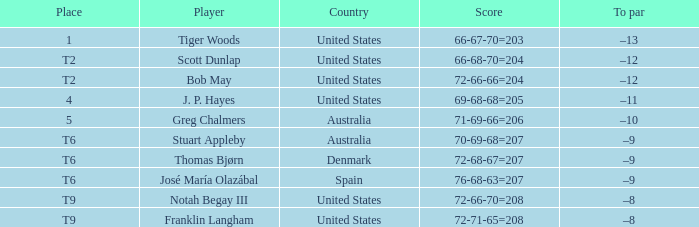Give me the full table as a dictionary. {'header': ['Place', 'Player', 'Country', 'Score', 'To par'], 'rows': [['1', 'Tiger Woods', 'United States', '66-67-70=203', '–13'], ['T2', 'Scott Dunlap', 'United States', '66-68-70=204', '–12'], ['T2', 'Bob May', 'United States', '72-66-66=204', '–12'], ['4', 'J. P. Hayes', 'United States', '69-68-68=205', '–11'], ['5', 'Greg Chalmers', 'Australia', '71-69-66=206', '–10'], ['T6', 'Stuart Appleby', 'Australia', '70-69-68=207', '–9'], ['T6', 'Thomas Bjørn', 'Denmark', '72-68-67=207', '–9'], ['T6', 'José María Olazábal', 'Spain', '76-68-63=207', '–9'], ['T9', 'Notah Begay III', 'United States', '72-66-70=208', '–8'], ['T9', 'Franklin Langham', 'United States', '72-71-65=208', '–8']]} What is the country of the player with a t6 place? Australia, Denmark, Spain. 